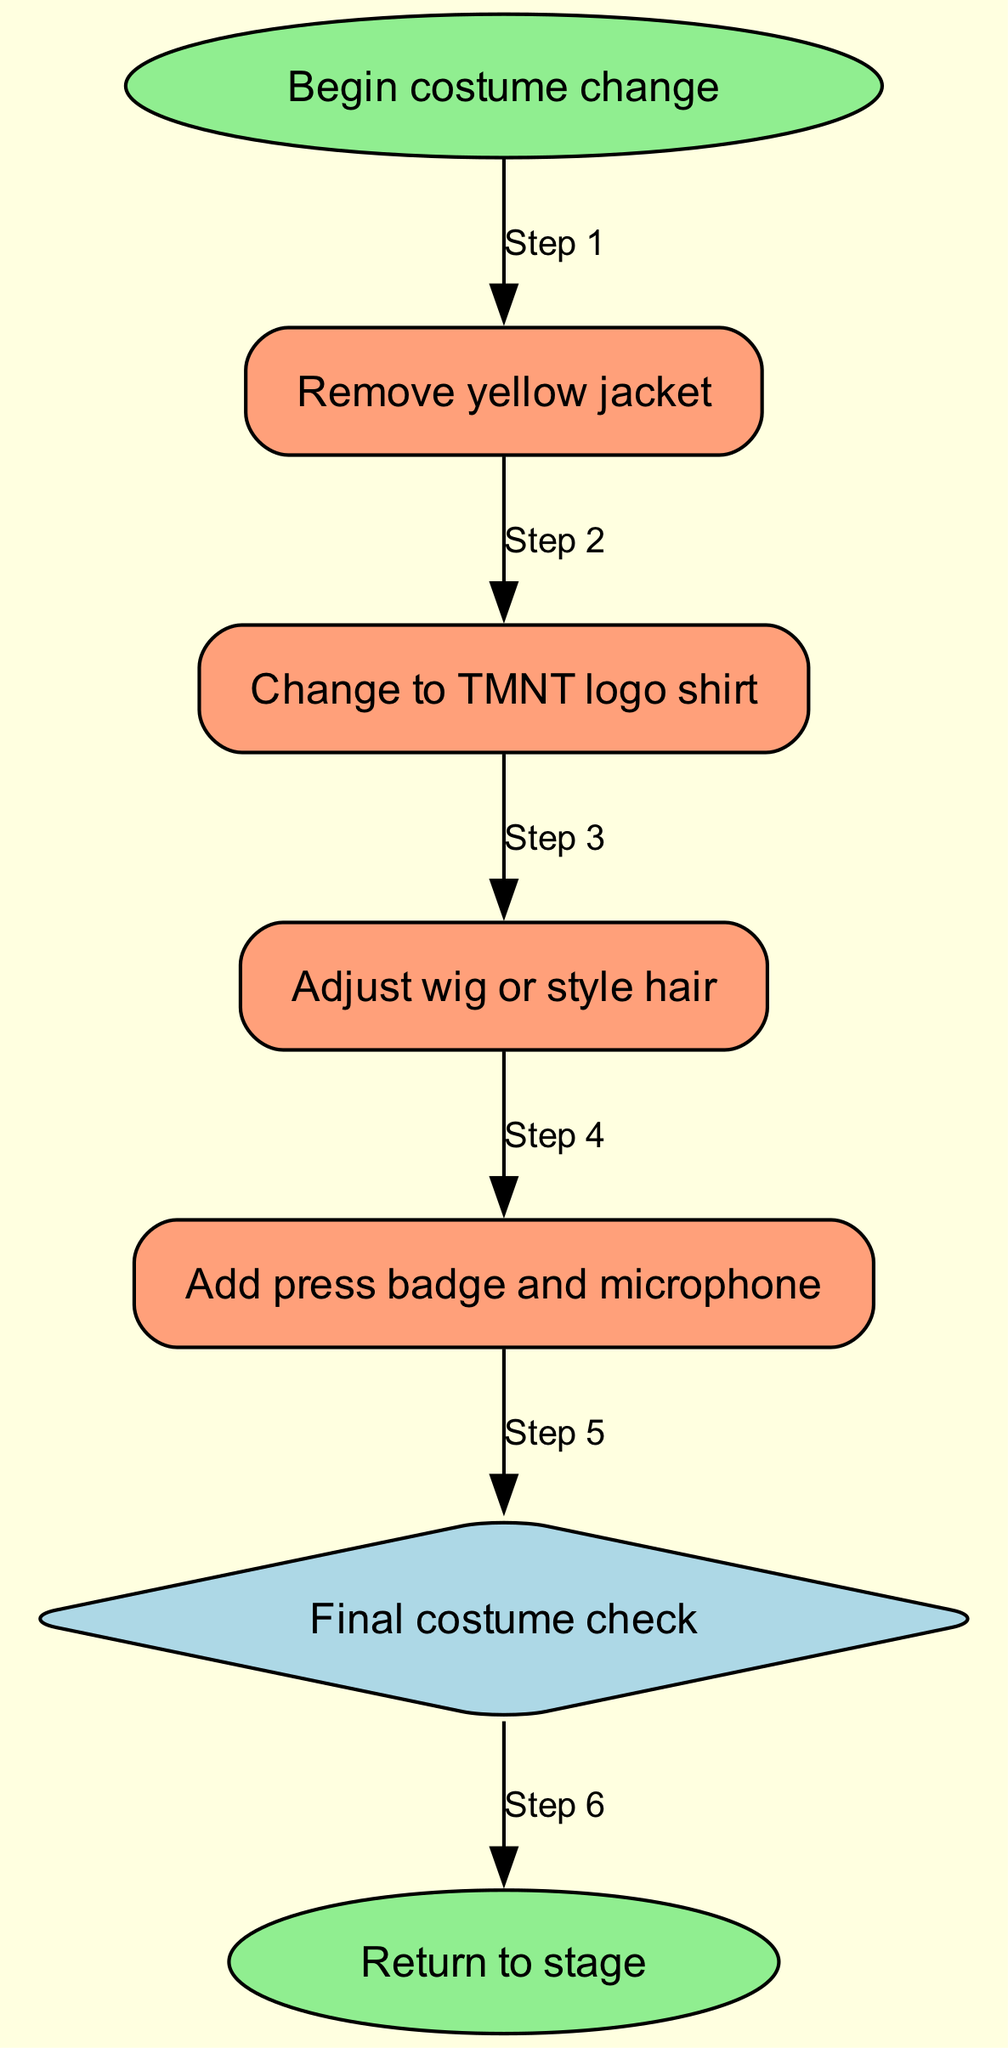What is the first step in the costume change sequence? The first step in the sequence is labeled as "Begin costume change," which initiates the process.
Answer: Begin costume change What node follows the removal of the yellow jacket? After "Remove yellow jacket," the next node is "Change to TMNT logo shirt," which indicates the subsequent action.
Answer: Change to TMNT logo shirt How many nodes are in the diagram? The diagram consists of six nodes, which include all the individual steps in the costume change process.
Answer: Six What is the last step before returning to the stage? The last step before returning to the stage is "Final costume check," which ensures everything is in order before going back.
Answer: Final costume check How many edges are present in the diagram? There are six edges in the diagram, connecting each step to the next in the costume change sequence.
Answer: Six Which step requires adjusting hair? The step that requires adjusting hair is "Adjust wig or style hair," which is directly after changing the shirt.
Answer: Adjust wig or style hair Which node is a decision point in the diagram? The node that serves as a decision point is "Final costume check," which checks if everything is ready before finishing.
Answer: Final costume check What color is used for the "Remove yellow jacket" node? The node "Remove yellow jacket" is colored lightsalmon, indicating it is a regular process step rather than a start or end point.
Answer: Lightsalmon How many steps are sequentially followed after starting the costume change? There are five steps that sequentially follow after starting the costume change, leading to the final check.
Answer: Five 